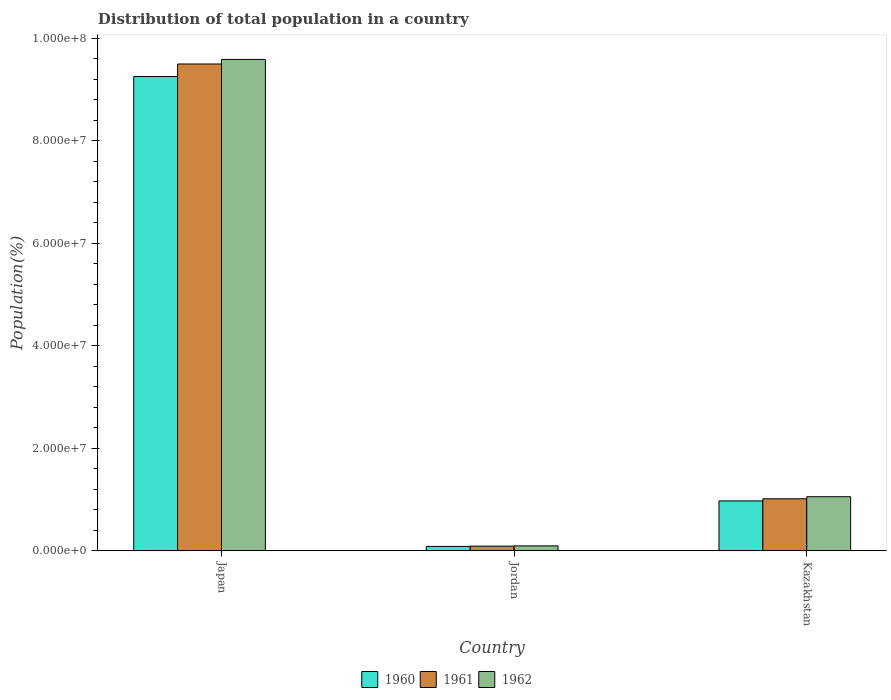What is the label of the 2nd group of bars from the left?
Your response must be concise. Jordan. What is the population of in 1960 in Jordan?
Make the answer very short. 8.44e+05. Across all countries, what is the maximum population of in 1961?
Keep it short and to the point. 9.49e+07. Across all countries, what is the minimum population of in 1962?
Provide a short and direct response. 9.43e+05. In which country was the population of in 1962 maximum?
Your answer should be very brief. Japan. In which country was the population of in 1960 minimum?
Give a very brief answer. Jordan. What is the total population of in 1960 in the graph?
Ensure brevity in your answer.  1.03e+08. What is the difference between the population of in 1960 in Japan and that in Jordan?
Provide a short and direct response. 9.17e+07. What is the difference between the population of in 1960 in Jordan and the population of in 1962 in Kazakhstan?
Your answer should be very brief. -9.69e+06. What is the average population of in 1960 per country?
Your answer should be very brief. 3.44e+07. What is the difference between the population of of/in 1961 and population of of/in 1962 in Japan?
Your answer should be very brief. -8.89e+05. In how many countries, is the population of in 1960 greater than 48000000 %?
Provide a short and direct response. 1. What is the ratio of the population of in 1962 in Japan to that in Kazakhstan?
Provide a short and direct response. 9.1. Is the population of in 1961 in Japan less than that in Jordan?
Offer a very short reply. No. What is the difference between the highest and the second highest population of in 1962?
Keep it short and to the point. 9.49e+07. What is the difference between the highest and the lowest population of in 1960?
Provide a succinct answer. 9.17e+07. In how many countries, is the population of in 1960 greater than the average population of in 1960 taken over all countries?
Provide a succinct answer. 1. What does the 2nd bar from the right in Kazakhstan represents?
Make the answer very short. 1961. How many bars are there?
Offer a very short reply. 9. Are all the bars in the graph horizontal?
Keep it short and to the point. No. What is the difference between two consecutive major ticks on the Y-axis?
Provide a succinct answer. 2.00e+07. Does the graph contain grids?
Your answer should be compact. No. Where does the legend appear in the graph?
Offer a very short reply. Bottom center. How many legend labels are there?
Keep it short and to the point. 3. How are the legend labels stacked?
Give a very brief answer. Horizontal. What is the title of the graph?
Ensure brevity in your answer.  Distribution of total population in a country. What is the label or title of the X-axis?
Give a very brief answer. Country. What is the label or title of the Y-axis?
Make the answer very short. Population(%). What is the Population(%) of 1960 in Japan?
Offer a terse response. 9.25e+07. What is the Population(%) of 1961 in Japan?
Your answer should be very brief. 9.49e+07. What is the Population(%) of 1962 in Japan?
Provide a short and direct response. 9.58e+07. What is the Population(%) of 1960 in Jordan?
Your response must be concise. 8.44e+05. What is the Population(%) of 1961 in Jordan?
Offer a very short reply. 8.91e+05. What is the Population(%) in 1962 in Jordan?
Your response must be concise. 9.43e+05. What is the Population(%) in 1960 in Kazakhstan?
Give a very brief answer. 9.71e+06. What is the Population(%) of 1961 in Kazakhstan?
Your answer should be compact. 1.01e+07. What is the Population(%) of 1962 in Kazakhstan?
Make the answer very short. 1.05e+07. Across all countries, what is the maximum Population(%) in 1960?
Your answer should be very brief. 9.25e+07. Across all countries, what is the maximum Population(%) of 1961?
Offer a very short reply. 9.49e+07. Across all countries, what is the maximum Population(%) of 1962?
Give a very brief answer. 9.58e+07. Across all countries, what is the minimum Population(%) of 1960?
Offer a very short reply. 8.44e+05. Across all countries, what is the minimum Population(%) of 1961?
Make the answer very short. 8.91e+05. Across all countries, what is the minimum Population(%) of 1962?
Keep it short and to the point. 9.43e+05. What is the total Population(%) of 1960 in the graph?
Your response must be concise. 1.03e+08. What is the total Population(%) of 1961 in the graph?
Offer a terse response. 1.06e+08. What is the total Population(%) of 1962 in the graph?
Offer a terse response. 1.07e+08. What is the difference between the Population(%) of 1960 in Japan and that in Jordan?
Provide a short and direct response. 9.17e+07. What is the difference between the Population(%) in 1961 in Japan and that in Jordan?
Provide a short and direct response. 9.41e+07. What is the difference between the Population(%) in 1962 in Japan and that in Jordan?
Provide a short and direct response. 9.49e+07. What is the difference between the Population(%) of 1960 in Japan and that in Kazakhstan?
Provide a short and direct response. 8.28e+07. What is the difference between the Population(%) in 1961 in Japan and that in Kazakhstan?
Your response must be concise. 8.48e+07. What is the difference between the Population(%) of 1962 in Japan and that in Kazakhstan?
Your answer should be very brief. 8.53e+07. What is the difference between the Population(%) of 1960 in Jordan and that in Kazakhstan?
Provide a short and direct response. -8.87e+06. What is the difference between the Population(%) in 1961 in Jordan and that in Kazakhstan?
Offer a terse response. -9.24e+06. What is the difference between the Population(%) in 1962 in Jordan and that in Kazakhstan?
Keep it short and to the point. -9.59e+06. What is the difference between the Population(%) in 1960 in Japan and the Population(%) in 1961 in Jordan?
Offer a terse response. 9.16e+07. What is the difference between the Population(%) in 1960 in Japan and the Population(%) in 1962 in Jordan?
Provide a short and direct response. 9.16e+07. What is the difference between the Population(%) of 1961 in Japan and the Population(%) of 1962 in Jordan?
Offer a very short reply. 9.40e+07. What is the difference between the Population(%) in 1960 in Japan and the Population(%) in 1961 in Kazakhstan?
Your answer should be very brief. 8.24e+07. What is the difference between the Population(%) in 1960 in Japan and the Population(%) in 1962 in Kazakhstan?
Your response must be concise. 8.20e+07. What is the difference between the Population(%) of 1961 in Japan and the Population(%) of 1962 in Kazakhstan?
Provide a short and direct response. 8.44e+07. What is the difference between the Population(%) of 1960 in Jordan and the Population(%) of 1961 in Kazakhstan?
Offer a terse response. -9.29e+06. What is the difference between the Population(%) of 1960 in Jordan and the Population(%) of 1962 in Kazakhstan?
Provide a short and direct response. -9.69e+06. What is the difference between the Population(%) in 1961 in Jordan and the Population(%) in 1962 in Kazakhstan?
Make the answer very short. -9.64e+06. What is the average Population(%) of 1960 per country?
Your response must be concise. 3.44e+07. What is the average Population(%) of 1961 per country?
Your answer should be compact. 3.53e+07. What is the average Population(%) in 1962 per country?
Offer a very short reply. 3.58e+07. What is the difference between the Population(%) in 1960 and Population(%) in 1961 in Japan?
Your answer should be compact. -2.44e+06. What is the difference between the Population(%) of 1960 and Population(%) of 1962 in Japan?
Offer a terse response. -3.33e+06. What is the difference between the Population(%) of 1961 and Population(%) of 1962 in Japan?
Provide a succinct answer. -8.89e+05. What is the difference between the Population(%) of 1960 and Population(%) of 1961 in Jordan?
Keep it short and to the point. -4.75e+04. What is the difference between the Population(%) of 1960 and Population(%) of 1962 in Jordan?
Offer a very short reply. -9.91e+04. What is the difference between the Population(%) in 1961 and Population(%) in 1962 in Jordan?
Make the answer very short. -5.16e+04. What is the difference between the Population(%) of 1960 and Population(%) of 1961 in Kazakhstan?
Your response must be concise. -4.16e+05. What is the difference between the Population(%) in 1960 and Population(%) in 1962 in Kazakhstan?
Your answer should be very brief. -8.18e+05. What is the difference between the Population(%) of 1961 and Population(%) of 1962 in Kazakhstan?
Ensure brevity in your answer.  -4.02e+05. What is the ratio of the Population(%) of 1960 in Japan to that in Jordan?
Offer a very short reply. 109.6. What is the ratio of the Population(%) in 1961 in Japan to that in Jordan?
Provide a succinct answer. 106.5. What is the ratio of the Population(%) in 1962 in Japan to that in Jordan?
Offer a very short reply. 101.61. What is the ratio of the Population(%) in 1960 in Japan to that in Kazakhstan?
Provide a succinct answer. 9.52. What is the ratio of the Population(%) in 1961 in Japan to that in Kazakhstan?
Make the answer very short. 9.37. What is the ratio of the Population(%) in 1962 in Japan to that in Kazakhstan?
Your answer should be very brief. 9.1. What is the ratio of the Population(%) in 1960 in Jordan to that in Kazakhstan?
Offer a very short reply. 0.09. What is the ratio of the Population(%) of 1961 in Jordan to that in Kazakhstan?
Provide a short and direct response. 0.09. What is the ratio of the Population(%) of 1962 in Jordan to that in Kazakhstan?
Give a very brief answer. 0.09. What is the difference between the highest and the second highest Population(%) of 1960?
Your answer should be very brief. 8.28e+07. What is the difference between the highest and the second highest Population(%) of 1961?
Give a very brief answer. 8.48e+07. What is the difference between the highest and the second highest Population(%) in 1962?
Offer a terse response. 8.53e+07. What is the difference between the highest and the lowest Population(%) in 1960?
Provide a short and direct response. 9.17e+07. What is the difference between the highest and the lowest Population(%) of 1961?
Provide a short and direct response. 9.41e+07. What is the difference between the highest and the lowest Population(%) in 1962?
Your answer should be very brief. 9.49e+07. 